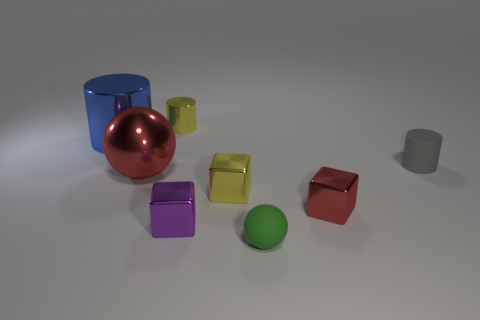What is the size of the blue object that is the same material as the small yellow block?
Offer a terse response. Large. The metal object that is the same shape as the small green matte thing is what size?
Keep it short and to the point. Large. Do the tiny gray cylinder and the cylinder that is on the left side of the big red sphere have the same material?
Your answer should be very brief. No. Are there any blue things of the same size as the matte sphere?
Ensure brevity in your answer.  No. What is the material of the ball that is the same size as the purple object?
Make the answer very short. Rubber. How many objects are metallic cylinders that are behind the big blue object or tiny blocks left of the tiny red cube?
Your answer should be very brief. 3. Is there a large object of the same shape as the small green thing?
Provide a short and direct response. Yes. What is the material of the small block that is the same color as the small metal cylinder?
Provide a short and direct response. Metal. How many matte objects are either yellow cylinders or cubes?
Provide a short and direct response. 0. The purple metallic object is what shape?
Keep it short and to the point. Cube. 